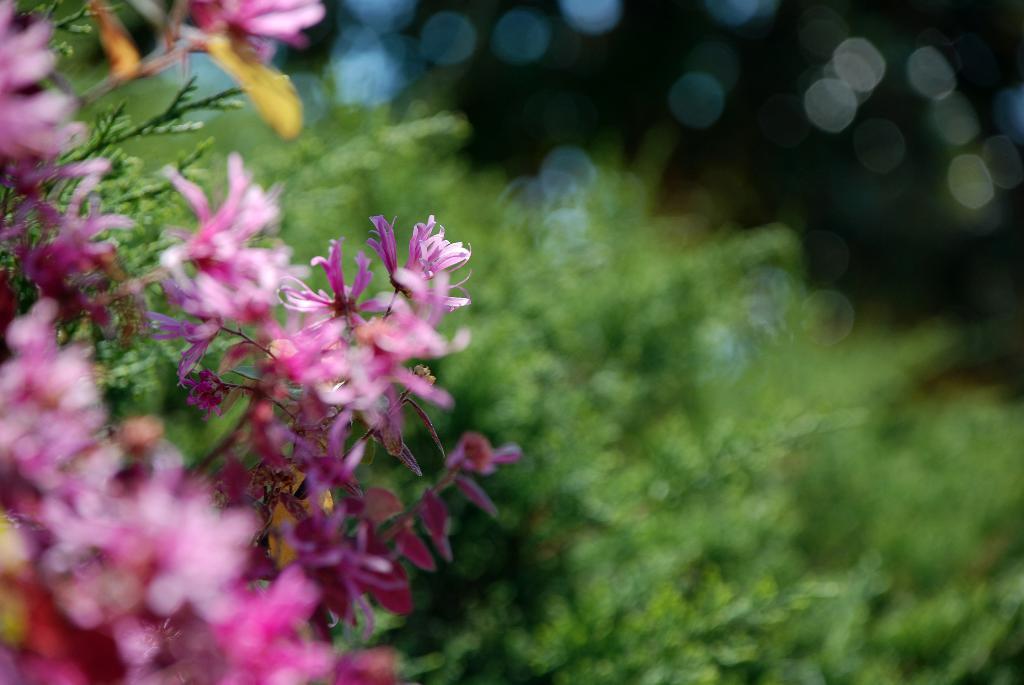Could you give a brief overview of what you see in this image? In this image in the foreground there are some flowers, and in the background there are some plants. 